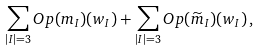Convert formula to latex. <formula><loc_0><loc_0><loc_500><loc_500>\sum _ { | I | = 3 } O p ( m _ { I } ) ( w _ { I } ) + \sum _ { | I | = 3 } O p ( \widetilde { m } _ { I } ) ( w _ { I } ) \, ,</formula> 